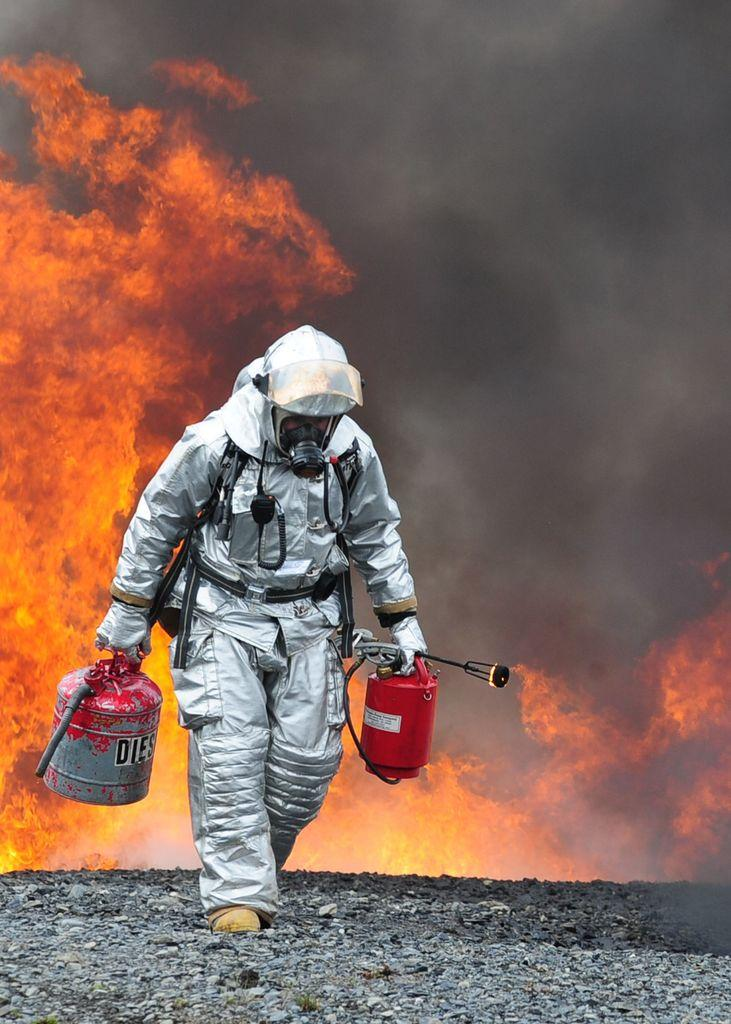What is the main subject of the image? There is a person in the image. What is the person standing on? The person is standing on stones. What objects is the person holding? The person is holding a diesel container and a fire extinguisher. What can be seen in the background of the image? There is a fire in the background of the image, and smoke is visible from the fire. How many answers does the person in the image have to provide to the jail warden? There is no jail or jail warden present in the image, so it is not possible to answer that question. 